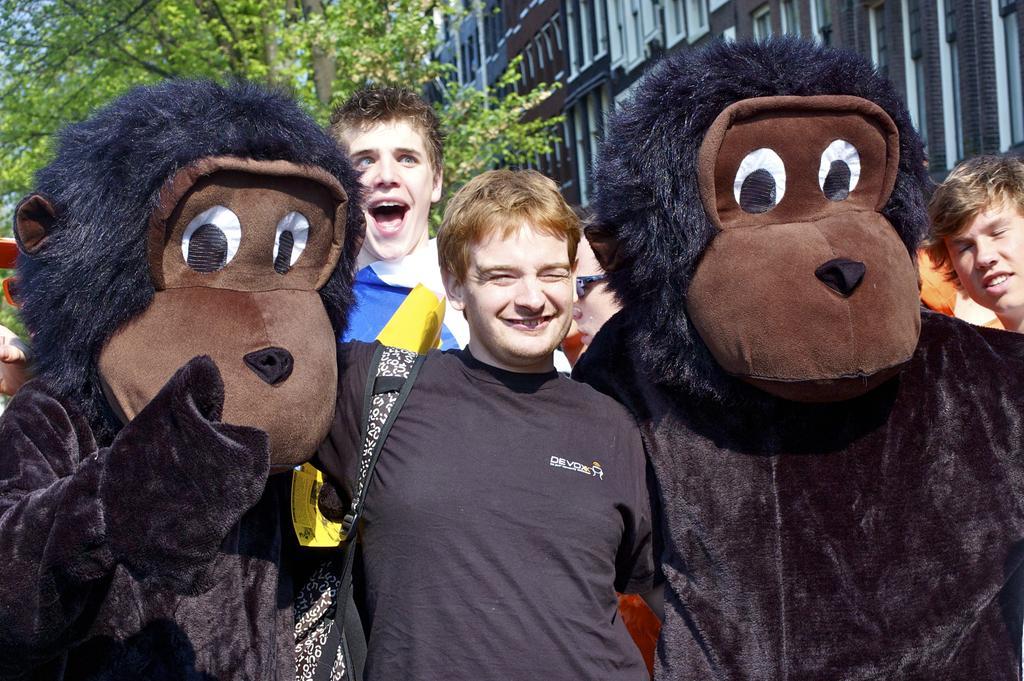How would you summarize this image in a sentence or two? In this picture there are people and we can see mascots. In the background of the image we can see building and tree. 